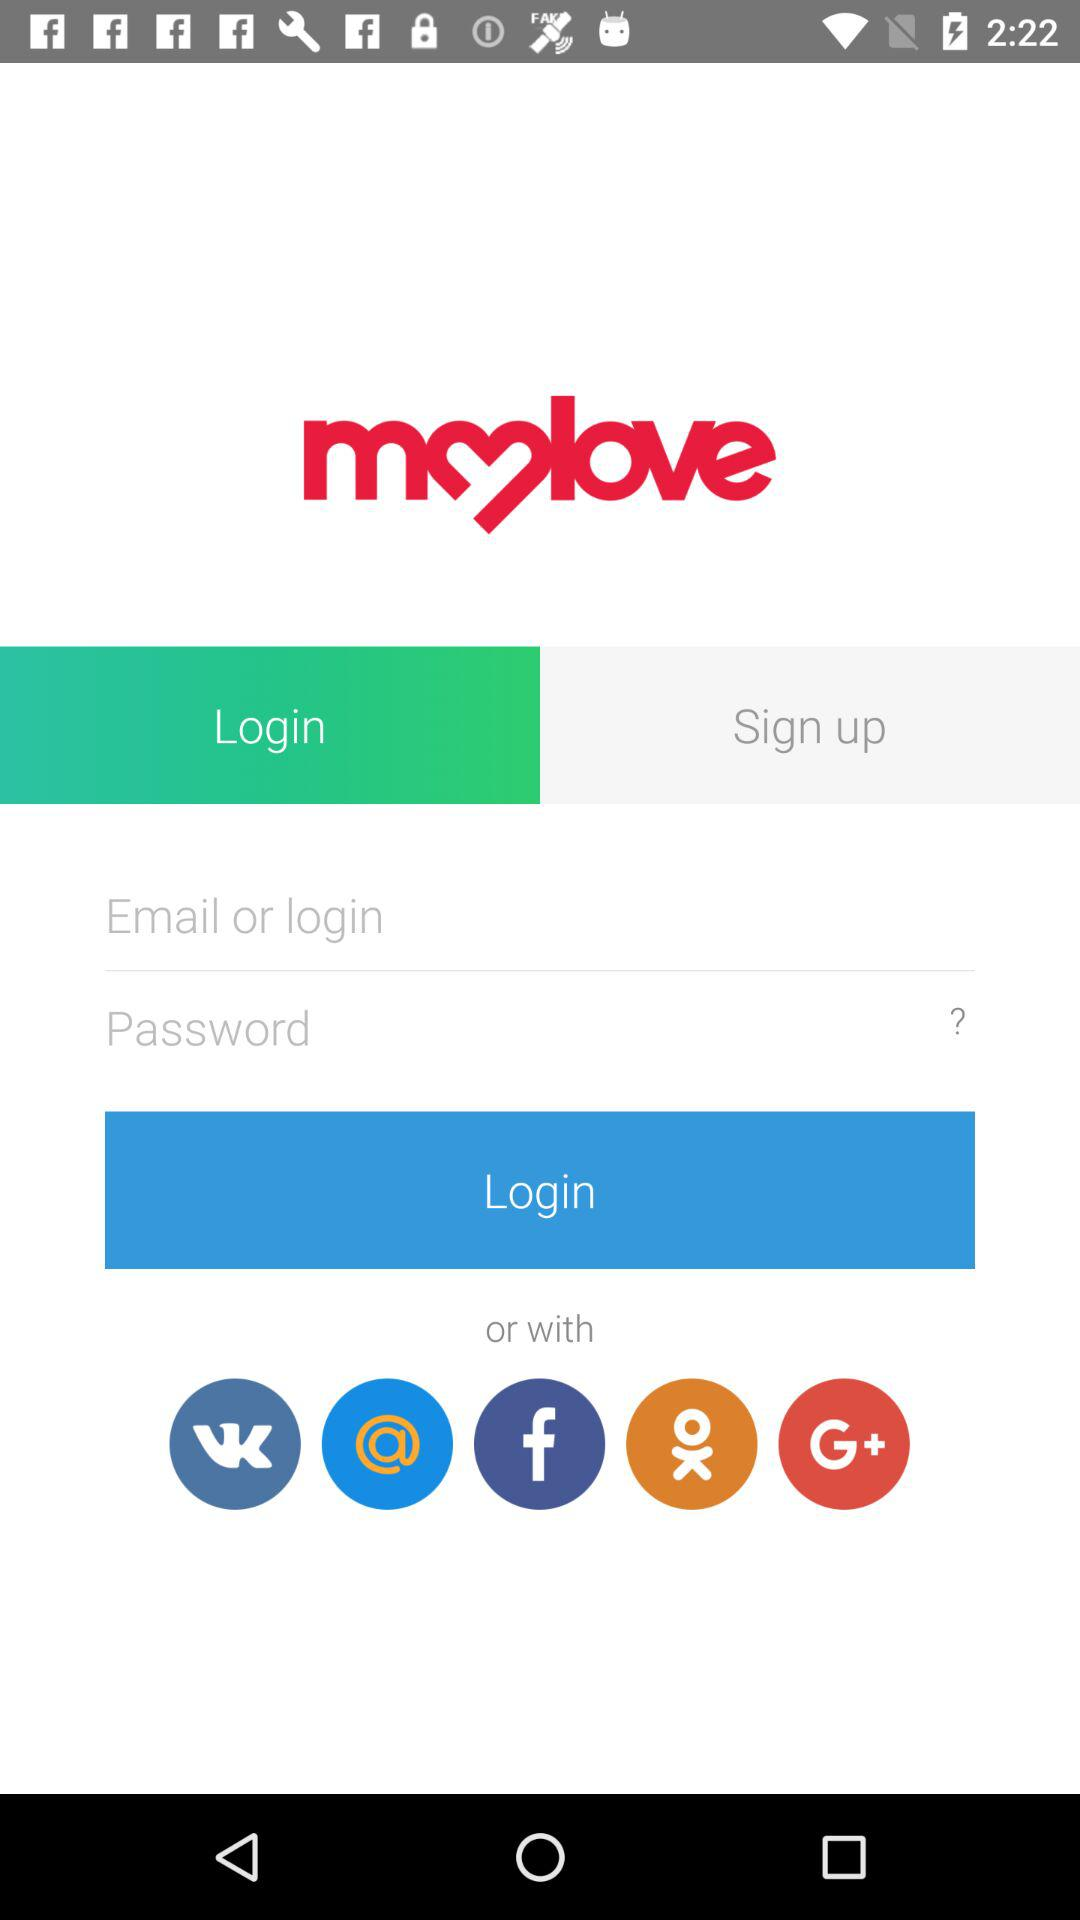What is the name of the application? The name of the application is "mylove". 